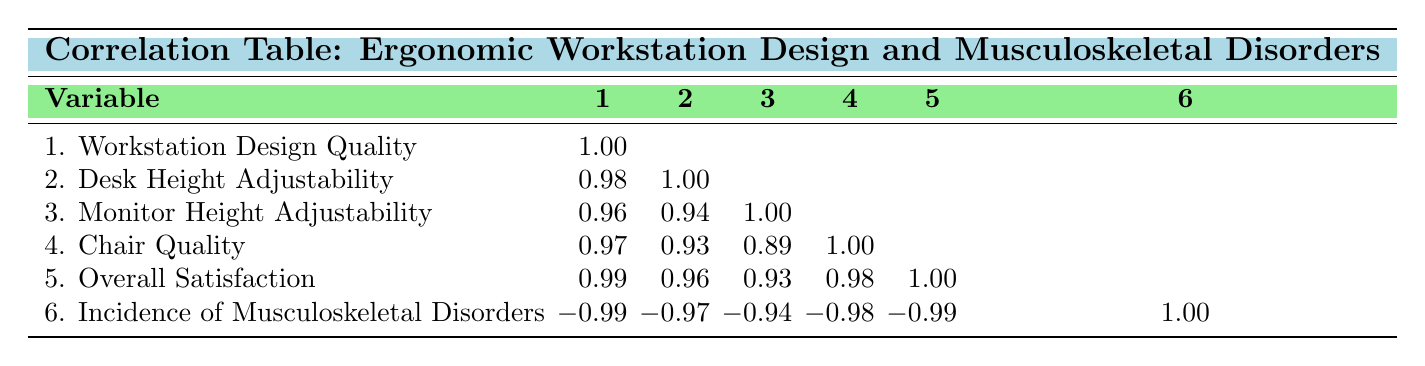What is the correlation between workstation design quality and incidence of musculoskeletal disorders? The correlation value between workstation design quality and incidence of musculoskeletal disorders is -0.99, indicating a strong negative relationship. As workstation design quality increases, the incidence of musculoskeletal disorders tends to decrease significantly.
Answer: -0.99 Which variable has the lowest correlation with overall satisfaction? The variable with the lowest correlation with overall satisfaction is monitor height adjustability, which has a correlation value of 0.93 with overall satisfaction. This indicates that it has a weaker relationship compared to other factors such as chair quality and desk height adjustability.
Answer: 0.93 True or False: Higher chair quality is associated with higher incidence of musculoskeletal disorders. This statement is false. The correlation between chair quality and incidence of musculoskeletal disorders is -0.98, indicating that as chair quality increases, the incidence of musculoskeletal disorders decreases significantly.
Answer: False What is the average correlation between desk height adjustability and the other four variables? To find the average correlation of desk height adjustability with the other four variables (workstation design quality, monitor height adjustability, chair quality, overall satisfaction), we add the correlations: 0.98 + 0.94 + 0.93 + 0.96 = 3.81, then divide by 4 to get the average: 3.81 / 4 = 0.9525.
Answer: 0.9525 Which variable shows the highest positive correlation with overall satisfaction? The variable that shows the highest positive correlation with overall satisfaction is workstation design quality, with a correlation value of 0.99. This indicates a very strong positive relationship; as workstation design quality increases, overall satisfaction also increases significantly.
Answer: 0.99 